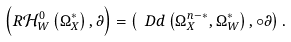Convert formula to latex. <formula><loc_0><loc_0><loc_500><loc_500>\left ( R \mathcal { H } _ { W } ^ { 0 } \left ( \Omega _ { X } ^ { * } \right ) , \partial \right ) = \left ( \ D d \left ( \Omega _ { X } ^ { n - * } , \Omega _ { W } ^ { * } \right ) , \circ \partial \right ) .</formula> 